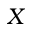<formula> <loc_0><loc_0><loc_500><loc_500>X</formula> 